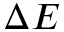<formula> <loc_0><loc_0><loc_500><loc_500>\Delta E</formula> 